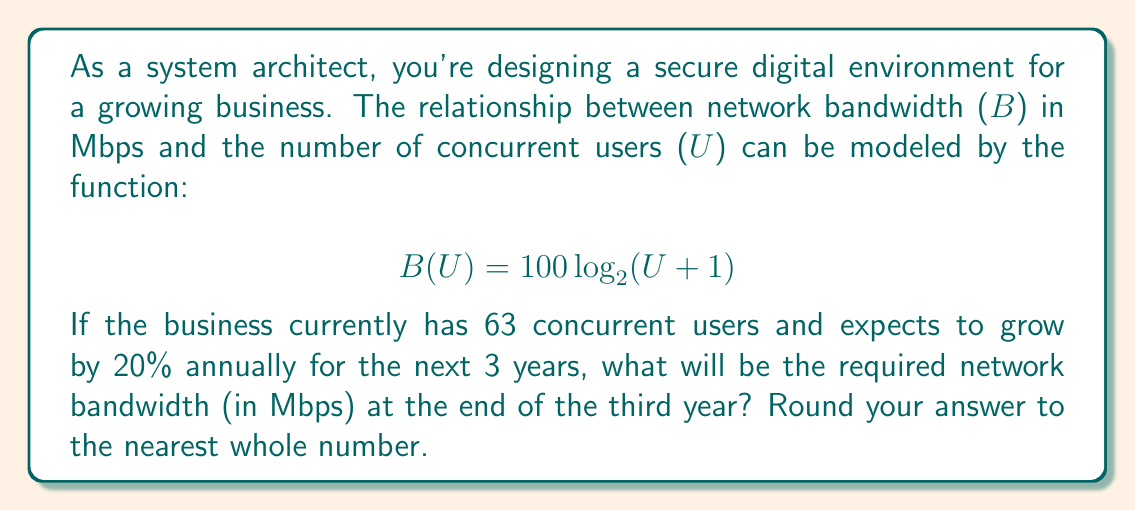Solve this math problem. To solve this problem, we'll follow these steps:

1. Calculate the number of users after 3 years of 20% annual growth.
2. Use the given function to determine the required bandwidth for that number of users.

Step 1: Calculate future user count
- Current users: 63
- Annual growth rate: 20% = 0.20
- Growth period: 3 years

We can use the compound growth formula:
$$ U_{final} = U_{initial} \times (1 + r)^n $$
Where $U_{final}$ is the final number of users, $U_{initial}$ is the initial number of users, $r$ is the growth rate, and $n$ is the number of years.

$$ U_{final} = 63 \times (1 + 0.20)^3 $$
$$ U_{final} = 63 \times 1.728 $$
$$ U_{final} = 108.864 $$

Rounding up to the nearest whole number: 109 users

Step 2: Calculate required bandwidth
Now we use the given function to determine the bandwidth:

$$ B(U) = 100 \log_{2}(U + 1) $$
$$ B(109) = 100 \log_{2}(109 + 1) $$
$$ B(109) = 100 \log_{2}(110) $$
$$ B(109) = 100 \times 6.78135971352466 $$
$$ B(109) = 678.135971352466 $$

Rounding to the nearest whole number: 678 Mbps
Answer: 678 Mbps 